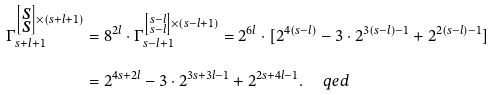<formula> <loc_0><loc_0><loc_500><loc_500>\Gamma _ { s + l + 1 } ^ { \left [ \substack { s \\ s } \right ] \times ( s + l + 1 ) } & = 8 ^ { 2 l } \cdot \Gamma _ { s - l + 1 } ^ { \left [ \substack { s - l \\ s - l } \right ] \times ( s - l + 1 ) } = 2 ^ { 6 l } \cdot [ 2 ^ { 4 ( s - l ) } - 3 \cdot 2 ^ { 3 ( s - l ) - 1 } + 2 ^ { 2 ( s - l ) - 1 } ] \\ & = 2 ^ { 4 s + 2 l } - 3 \cdot 2 ^ { 3 s + 3 l - 1 } + 2 ^ { 2 s + 4 l - 1 } . \quad \ q e d</formula> 